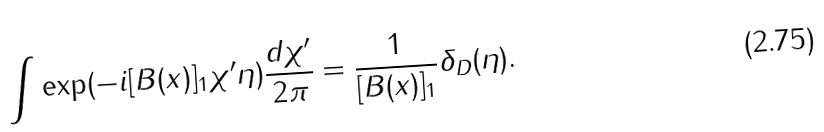Convert formula to latex. <formula><loc_0><loc_0><loc_500><loc_500>\int \exp ( - i [ B ( x ) ] _ { 1 } \chi ^ { \prime } \eta ) \frac { d \chi ^ { \prime } } { 2 \pi } = \frac { 1 } { [ B ( x ) ] _ { 1 } } \delta _ { D } ( \eta ) .</formula> 